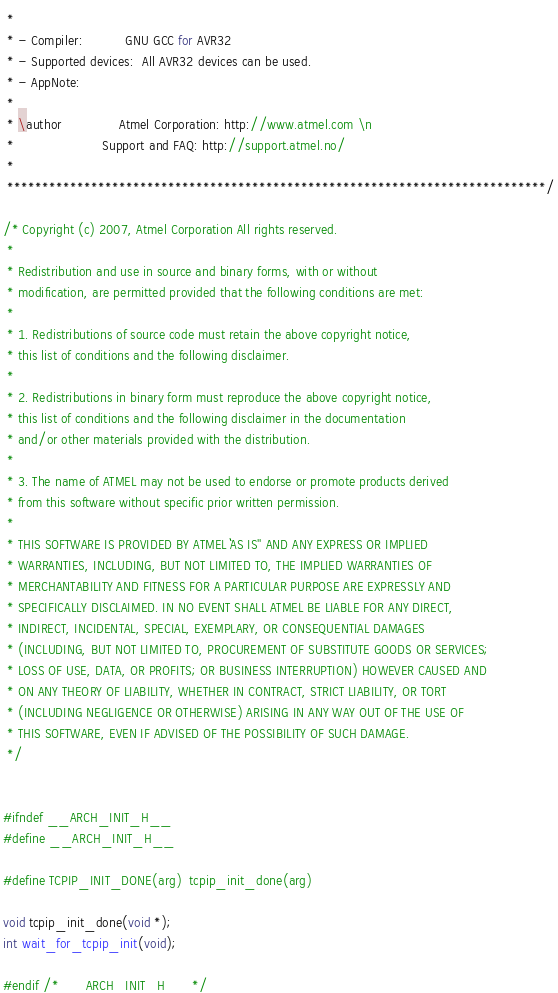Convert code to text. <code><loc_0><loc_0><loc_500><loc_500><_C_> *
 * - Compiler:           GNU GCC for AVR32
 * - Supported devices:  All AVR32 devices can be used.
 * - AppNote:
 *
 * \author               Atmel Corporation: http://www.atmel.com \n
 *                       Support and FAQ: http://support.atmel.no/
 *
 *****************************************************************************/

/* Copyright (c) 2007, Atmel Corporation All rights reserved.
 *
 * Redistribution and use in source and binary forms, with or without
 * modification, are permitted provided that the following conditions are met:
 *
 * 1. Redistributions of source code must retain the above copyright notice,
 * this list of conditions and the following disclaimer.
 *
 * 2. Redistributions in binary form must reproduce the above copyright notice,
 * this list of conditions and the following disclaimer in the documentation
 * and/or other materials provided with the distribution.
 *
 * 3. The name of ATMEL may not be used to endorse or promote products derived
 * from this software without specific prior written permission.
 *
 * THIS SOFTWARE IS PROVIDED BY ATMEL ``AS IS'' AND ANY EXPRESS OR IMPLIED
 * WARRANTIES, INCLUDING, BUT NOT LIMITED TO, THE IMPLIED WARRANTIES OF
 * MERCHANTABILITY AND FITNESS FOR A PARTICULAR PURPOSE ARE EXPRESSLY AND
 * SPECIFICALLY DISCLAIMED. IN NO EVENT SHALL ATMEL BE LIABLE FOR ANY DIRECT,
 * INDIRECT, INCIDENTAL, SPECIAL, EXEMPLARY, OR CONSEQUENTIAL DAMAGES
 * (INCLUDING, BUT NOT LIMITED TO, PROCUREMENT OF SUBSTITUTE GOODS OR SERVICES;
 * LOSS OF USE, DATA, OR PROFITS; OR BUSINESS INTERRUPTION) HOWEVER CAUSED AND
 * ON ANY THEORY OF LIABILITY, WHETHER IN CONTRACT, STRICT LIABILITY, OR TORT
 * (INCLUDING NEGLIGENCE OR OTHERWISE) ARISING IN ANY WAY OUT OF THE USE OF
 * THIS SOFTWARE, EVEN IF ADVISED OF THE POSSIBILITY OF SUCH DAMAGE.
 */


#ifndef __ARCH_INIT_H__
#define __ARCH_INIT_H__

#define TCPIP_INIT_DONE(arg)  tcpip_init_done(arg)

void tcpip_init_done(void *);
int wait_for_tcpip_init(void);

#endif /* __ARCH_INIT_H__ */




</code> 